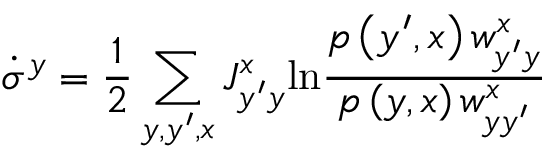Convert formula to latex. <formula><loc_0><loc_0><loc_500><loc_500>\dot { \sigma } ^ { y } = \frac { 1 } { 2 } \sum _ { y , y ^ { \prime } , x } J _ { y ^ { \prime } y } ^ { x } \ln \frac { p \left ( y ^ { \prime } , x \right ) w _ { y ^ { \prime } y } ^ { x } } { p \left ( y , x \right ) w _ { y y ^ { \prime } } ^ { x } }</formula> 